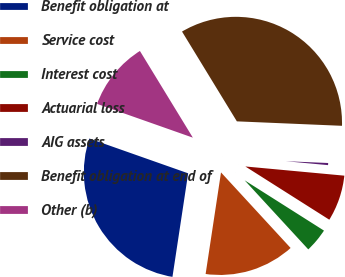Convert chart to OTSL. <chart><loc_0><loc_0><loc_500><loc_500><pie_chart><fcel>Benefit obligation at<fcel>Service cost<fcel>Interest cost<fcel>Actuarial loss<fcel>AIG assets<fcel>Benefit obligation at end of<fcel>Other (b)<nl><fcel>28.0%<fcel>14.24%<fcel>4.16%<fcel>7.52%<fcel>0.8%<fcel>34.4%<fcel>10.88%<nl></chart> 